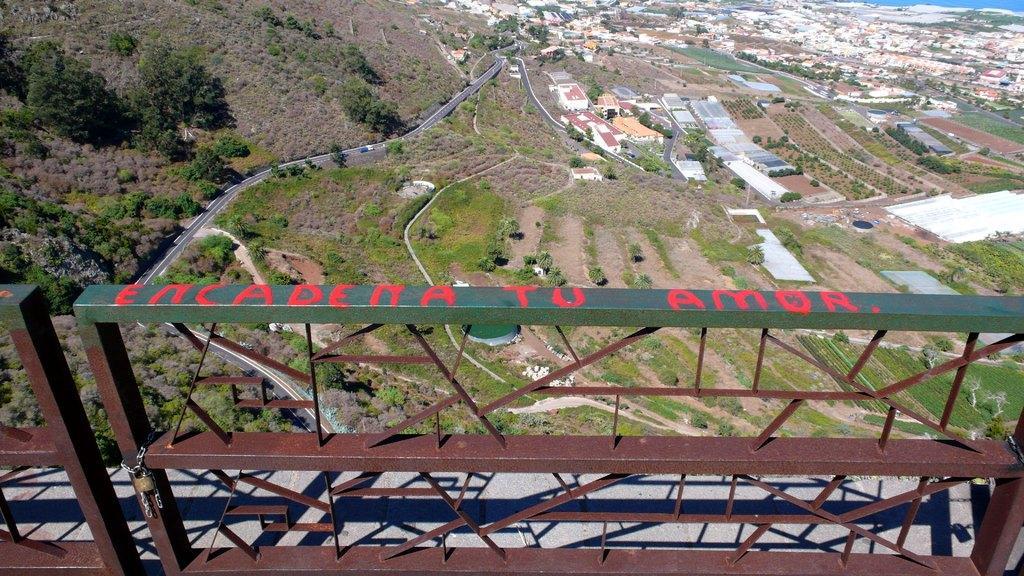How would you summarize this image in a sentence or two? In the image we can see there are iron railings and there are lot of trees on the ground. There are buildings and there is road. Background of the image is little blurred. 